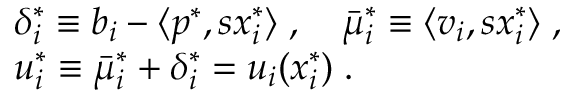<formula> <loc_0><loc_0><loc_500><loc_500>\begin{array} { r l } & { { \delta _ { i } ^ { * } } \equiv b _ { i } - { \langle } p ^ { * } , s { x _ { i } ^ { * } } { \rangle } \, , \quad \bar { \mu } _ { i } ^ { * } \equiv \langle v _ { i } , s { x _ { i } ^ { * } } { \rangle } \, , } \\ & { { u _ { i } ^ { * } } \equiv \bar { \mu } _ { i } ^ { * } + { \delta _ { i } ^ { * } } = u _ { i } ( { x _ { i } ^ { * } } ) \, . } \end{array}</formula> 